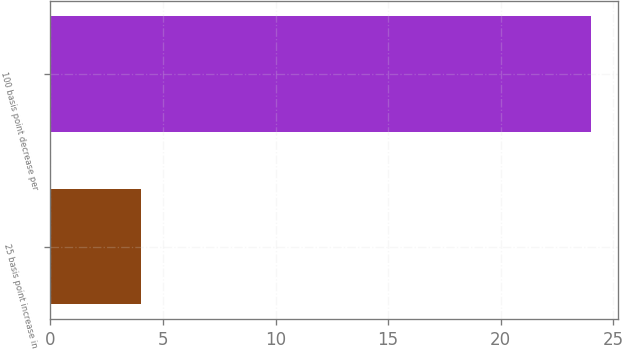Convert chart to OTSL. <chart><loc_0><loc_0><loc_500><loc_500><bar_chart><fcel>25 basis point increase in<fcel>100 basis point decrease per<nl><fcel>4<fcel>24<nl></chart> 